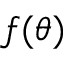Convert formula to latex. <formula><loc_0><loc_0><loc_500><loc_500>f ( \theta )</formula> 